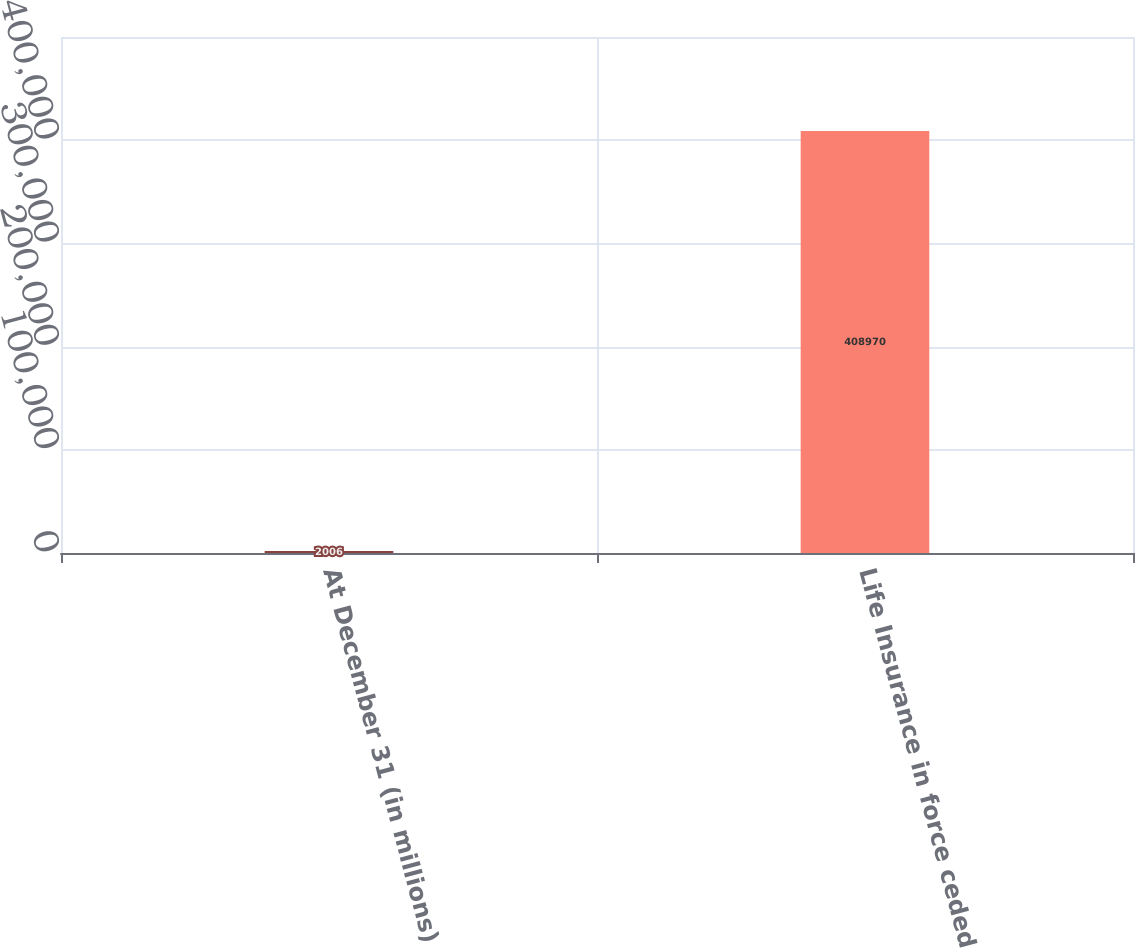Convert chart. <chart><loc_0><loc_0><loc_500><loc_500><bar_chart><fcel>At December 31 (in millions)<fcel>Life Insurance in force ceded<nl><fcel>2006<fcel>408970<nl></chart> 